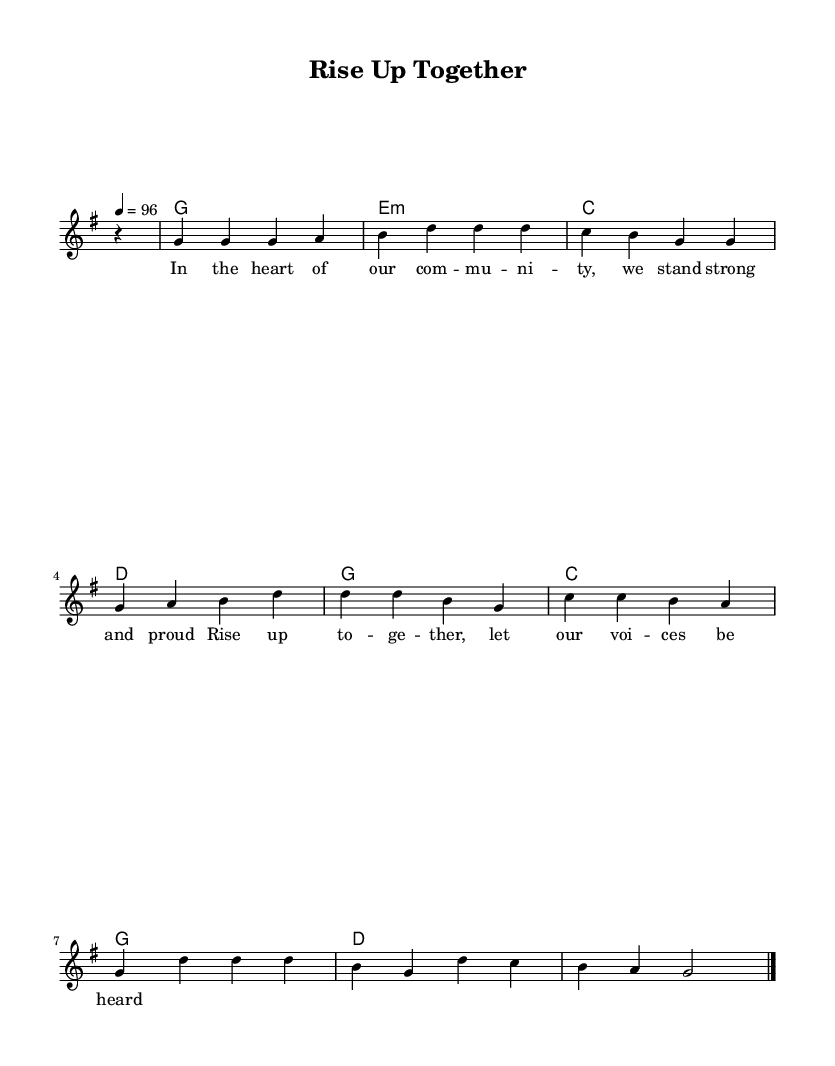What is the key signature of this music? The key signature indicated in the music sheet is G major, which has one sharp (F#). This is determined by examining the global section where the key is set to 'g'.
Answer: G major What is the time signature of the piece? The time signature is 4/4, as clearly indicated in the global section under 'time'. This means there are four beats in a measure and the quarter note gets one beat.
Answer: 4/4 What is the tempo marking for this piece? The tempo is marked as quarter note equals 96, indicated in the global section. This suggests how fast the music should be played, with 96 quarter notes occurring in one minute.
Answer: 96 How many measures are there in the melody? Counting the measures in the melody section, there are eight measures present in total. Each measure is separated with a vertical line.
Answer: Eight What emotion or theme does the lyrics express? The lyrics reflect themes of community, strength, and empowerment, as indicated by the phrases like "stand strong and proud" and "let our voices be heard". This suggests a supportive and uplifting message typical of soul music.
Answer: Empowerment How many harmony chords are used in the progression? The harmony section indicates there are eight chord changes, which are listed throughout the section. Each change signifies a different chord played along with the melody.
Answer: Eight What genre does this music belong to? The music, characterized by the rhythmic soul patterns and themes of community empowerment, clearly falls under the genre of soul, a style known for its emotional depth and social themes.
Answer: Soul 